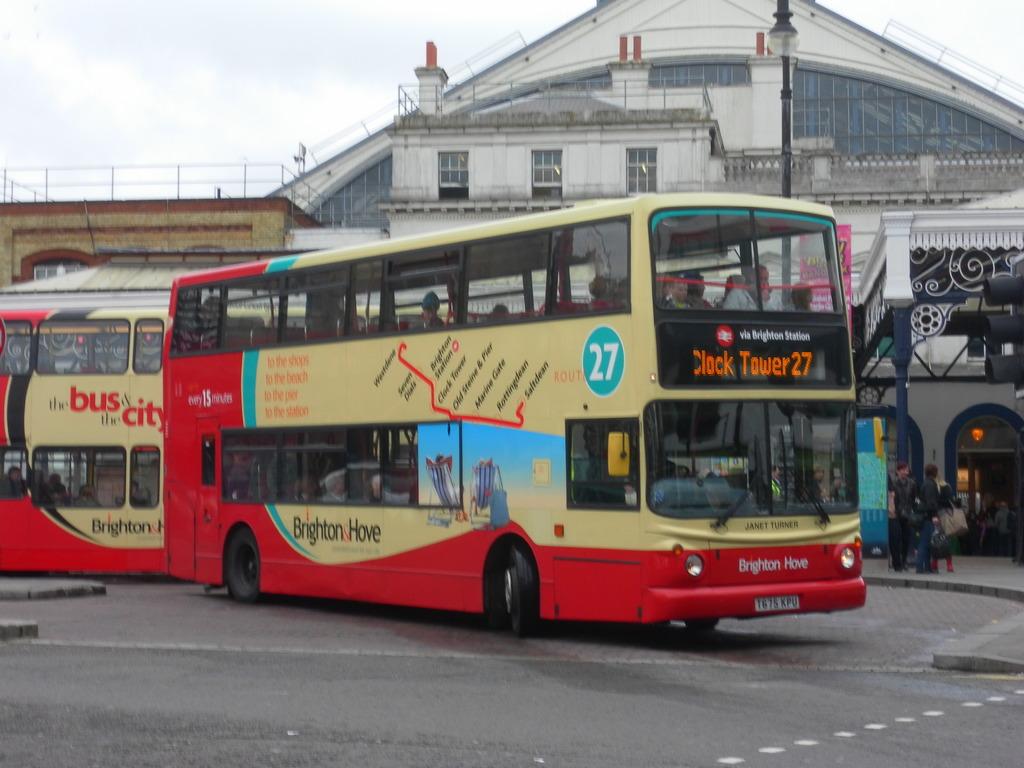Where is this bus's destination?
Offer a very short reply. Clock tower 27. 